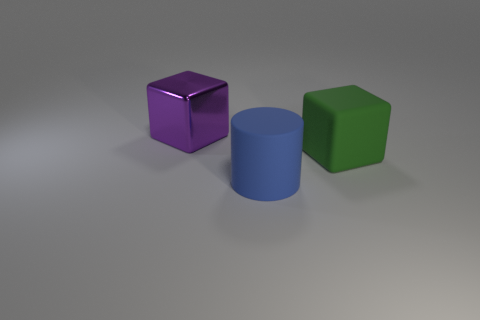Add 2 blue things. How many objects exist? 5 Subtract all cubes. How many objects are left? 1 Subtract all green metal things. Subtract all large rubber cubes. How many objects are left? 2 Add 3 purple things. How many purple things are left? 4 Add 2 big green metallic things. How many big green metallic things exist? 2 Subtract 0 gray cubes. How many objects are left? 3 